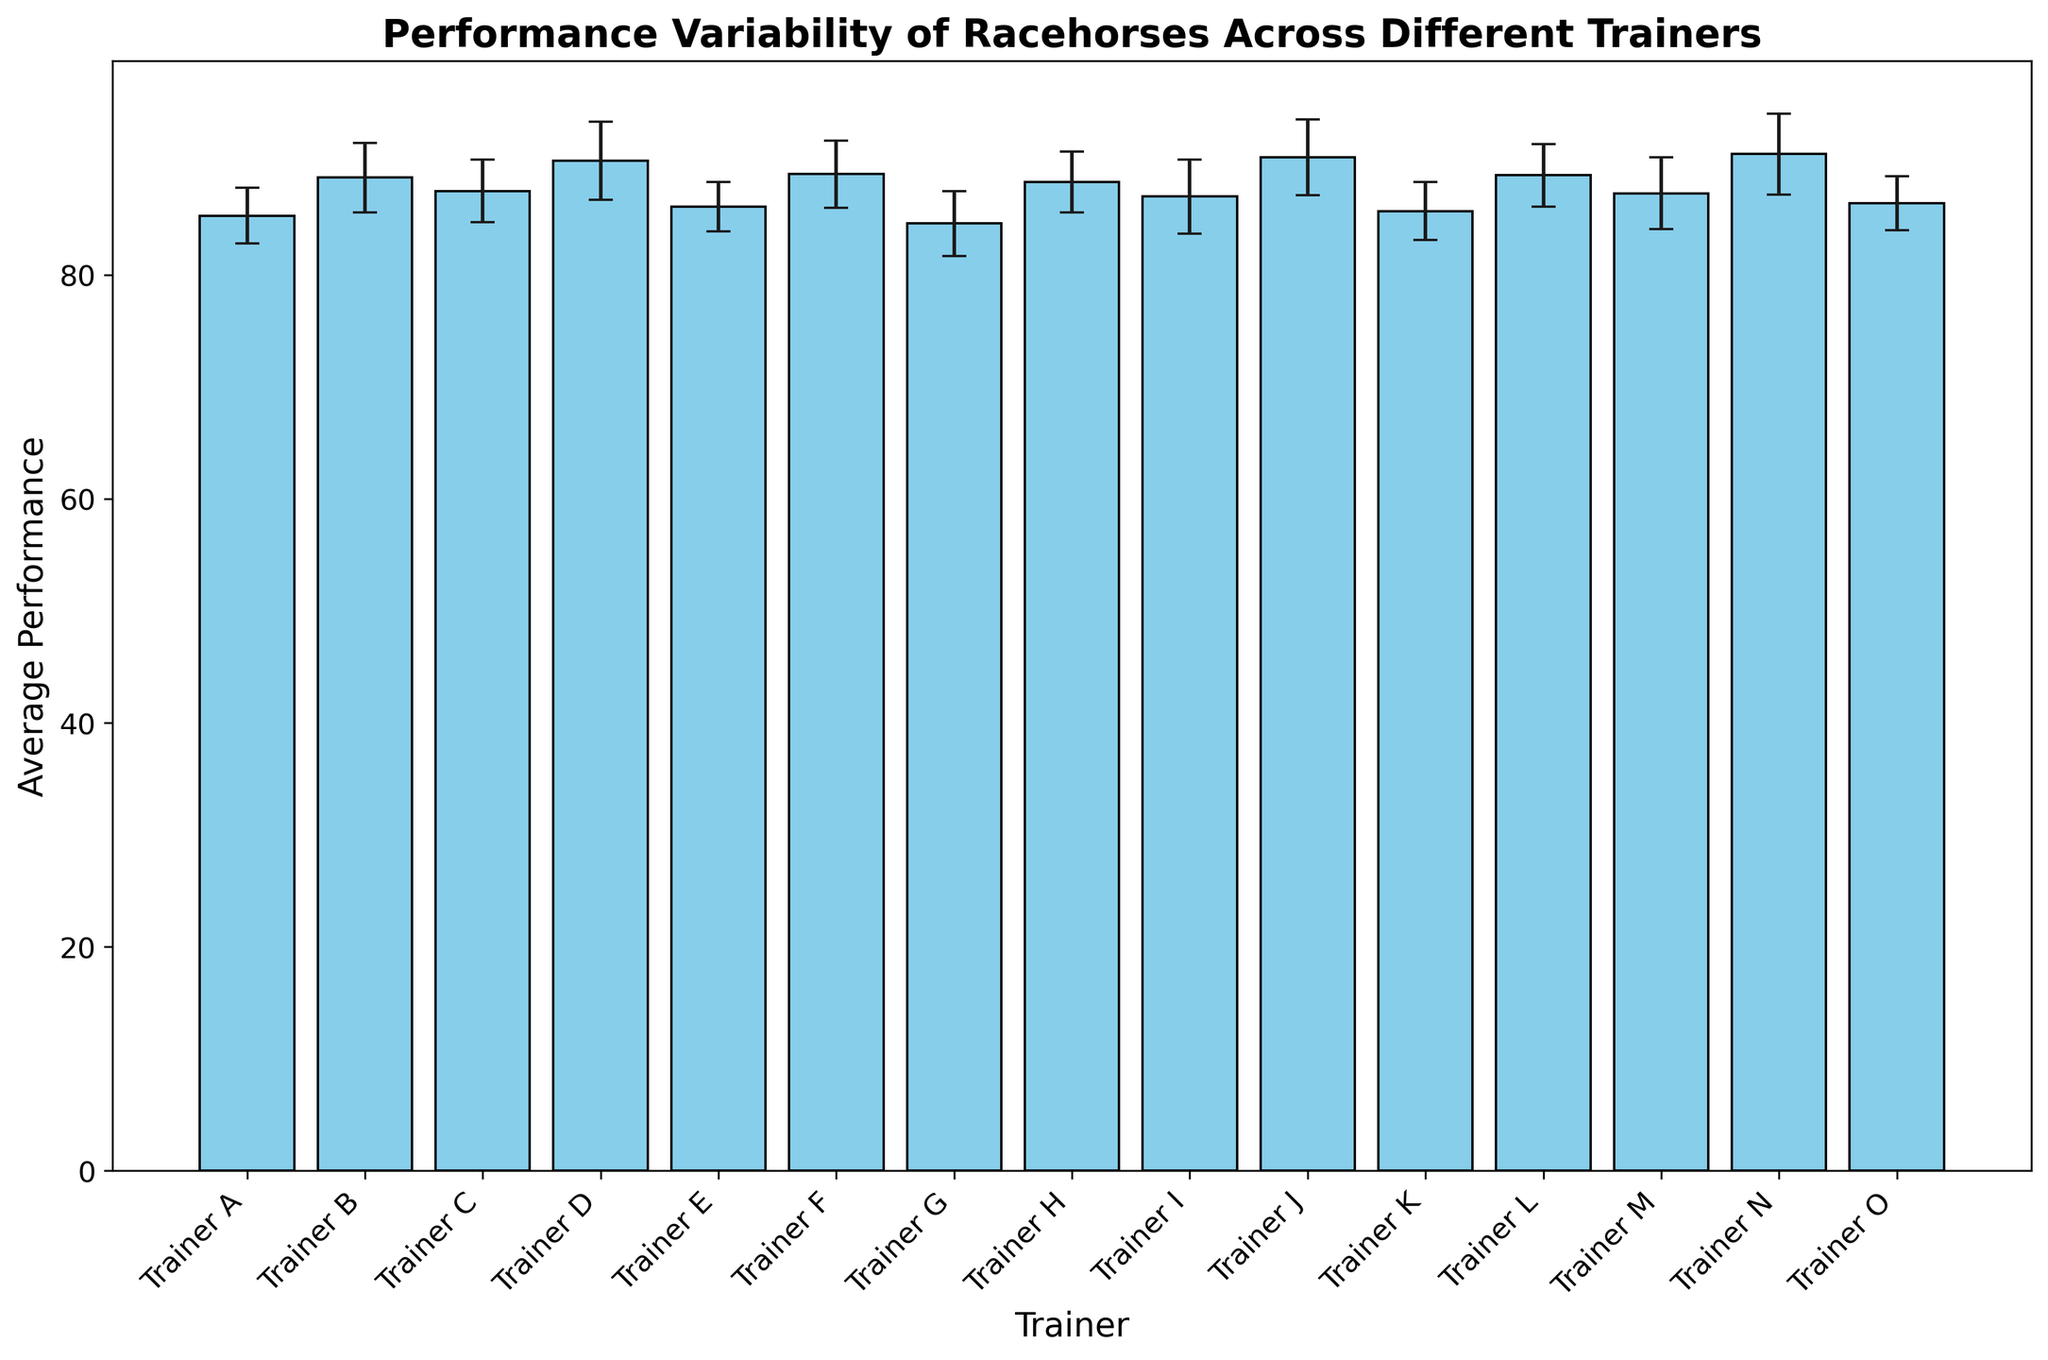How many trainers have an average performance above 88? First, identify the trainers with average performance values above 88, which are Trainer B, Trainer D, Trainer F, Trainer J, Trainer L, and Trainer N. There are 6 such trainers.
Answer: 6 Which trainer has the highest average performance? Look at the bars representing average performance and find the tallest bar. The tallest bar corresponds to Trainer N, who has the highest average performance of 90.8.
Answer: Trainer N How does the performance of Trainer G compare to that of Trainer K? Observe the bars for Trainer G and Trainer K. Trainer G has an average performance of 84.6, while Trainer K has an average performance of 85.7. Hence, Trainer K has a higher average performance than Trainer G.
Answer: Trainer K has a higher average performance than Trainer G Which trainer has the smallest standard deviation in performance? Examine the error bars (vertical lines) associated with each trainer's bar. The trainer with the shortest error bar is Trainer E, with a standard deviation of 2.2.
Answer: Trainer E What is the range of average performance values among all trainers? Identify the lowest and highest average performance values from the bars. The lowest is 84.6 (Trainer G) and the highest is 90.8 (Trainer N). Subtract the lowest from the highest: 90.8 - 84.6 = 6.2.
Answer: 6.2 Among Trainers D, J, and N, who shows the greatest variability in performance? Compare the lengths of the error bars for Trainers D, J, and N. Trainer N has the longest error bar with a standard deviation of 3.6, indicating the greatest variability.
Answer: Trainer N What is the average performance of Trainers B, D, and N? Sum the average performances of Trainers B, D, and N: 88.7 + 90.2 + 90.8 = 269.7. Divide by the number of trainers (3): 269.7 / 3 = 89.9.
Answer: 89.9 Which two trainers have the closest average performance values? Identify trainers with average performances very close to each other. Trainers K (85.7) and A (85.3) have average performances close to each other, with a difference of 0.4.
Answer: Trainer K and Trainer A How does the performance variability of Trainer B compare to Trainer E? Compare the lengths of the error bars for Trainers B and E. Trainer B has a standard deviation of 3.1, whereas Trainer E has a shorter standard deviation of 2.2, meaning Trainer B has higher variability.
Answer: Trainer B has higher variability than Trainer E 